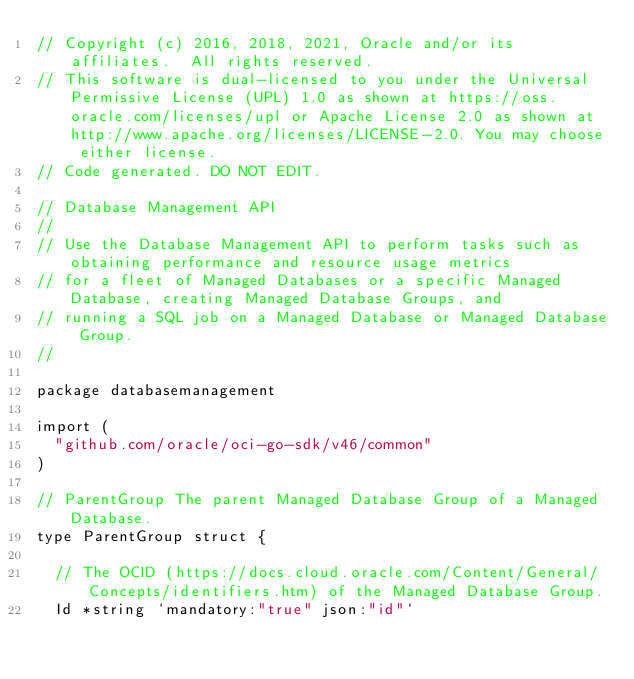Convert code to text. <code><loc_0><loc_0><loc_500><loc_500><_Go_>// Copyright (c) 2016, 2018, 2021, Oracle and/or its affiliates.  All rights reserved.
// This software is dual-licensed to you under the Universal Permissive License (UPL) 1.0 as shown at https://oss.oracle.com/licenses/upl or Apache License 2.0 as shown at http://www.apache.org/licenses/LICENSE-2.0. You may choose either license.
// Code generated. DO NOT EDIT.

// Database Management API
//
// Use the Database Management API to perform tasks such as obtaining performance and resource usage metrics
// for a fleet of Managed Databases or a specific Managed Database, creating Managed Database Groups, and
// running a SQL job on a Managed Database or Managed Database Group.
//

package databasemanagement

import (
	"github.com/oracle/oci-go-sdk/v46/common"
)

// ParentGroup The parent Managed Database Group of a Managed Database.
type ParentGroup struct {

	// The OCID (https://docs.cloud.oracle.com/Content/General/Concepts/identifiers.htm) of the Managed Database Group.
	Id *string `mandatory:"true" json:"id"`
</code> 